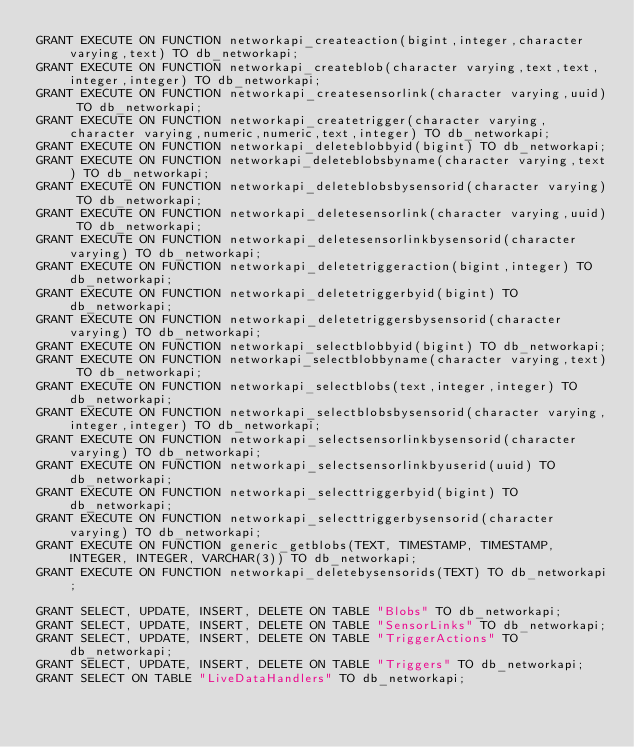<code> <loc_0><loc_0><loc_500><loc_500><_SQL_>GRANT EXECUTE ON FUNCTION networkapi_createaction(bigint,integer,character varying,text) TO db_networkapi;
GRANT EXECUTE ON FUNCTION networkapi_createblob(character varying,text,text,integer,integer) TO db_networkapi;
GRANT EXECUTE ON FUNCTION networkapi_createsensorlink(character varying,uuid) TO db_networkapi;
GRANT EXECUTE ON FUNCTION networkapi_createtrigger(character varying,character varying,numeric,numeric,text,integer) TO db_networkapi;
GRANT EXECUTE ON FUNCTION networkapi_deleteblobbyid(bigint) TO db_networkapi;
GRANT EXECUTE ON FUNCTION networkapi_deleteblobsbyname(character varying,text) TO db_networkapi;
GRANT EXECUTE ON FUNCTION networkapi_deleteblobsbysensorid(character varying) TO db_networkapi;
GRANT EXECUTE ON FUNCTION networkapi_deletesensorlink(character varying,uuid) TO db_networkapi;
GRANT EXECUTE ON FUNCTION networkapi_deletesensorlinkbysensorid(character varying) TO db_networkapi;
GRANT EXECUTE ON FUNCTION networkapi_deletetriggeraction(bigint,integer) TO db_networkapi;
GRANT EXECUTE ON FUNCTION networkapi_deletetriggerbyid(bigint) TO db_networkapi;
GRANT EXECUTE ON FUNCTION networkapi_deletetriggersbysensorid(character varying) TO db_networkapi;
GRANT EXECUTE ON FUNCTION networkapi_selectblobbyid(bigint) TO db_networkapi;
GRANT EXECUTE ON FUNCTION networkapi_selectblobbyname(character varying,text) TO db_networkapi;
GRANT EXECUTE ON FUNCTION networkapi_selectblobs(text,integer,integer) TO db_networkapi;
GRANT EXECUTE ON FUNCTION networkapi_selectblobsbysensorid(character varying,integer,integer) TO db_networkapi;
GRANT EXECUTE ON FUNCTION networkapi_selectsensorlinkbysensorid(character varying) TO db_networkapi;
GRANT EXECUTE ON FUNCTION networkapi_selectsensorlinkbyuserid(uuid) TO db_networkapi;
GRANT EXECUTE ON FUNCTION networkapi_selecttriggerbyid(bigint) TO db_networkapi;
GRANT EXECUTE ON FUNCTION networkapi_selecttriggerbysensorid(character varying) TO db_networkapi;
GRANT EXECUTE ON FUNCTION generic_getblobs(TEXT, TIMESTAMP, TIMESTAMP, INTEGER, INTEGER, VARCHAR(3)) TO db_networkapi;
GRANT EXECUTE ON FUNCTION networkapi_deletebysensorids(TEXT) TO db_networkapi;

GRANT SELECT, UPDATE, INSERT, DELETE ON TABLE "Blobs" TO db_networkapi;
GRANT SELECT, UPDATE, INSERT, DELETE ON TABLE "SensorLinks" TO db_networkapi;
GRANT SELECT, UPDATE, INSERT, DELETE ON TABLE "TriggerActions" TO db_networkapi;
GRANT SELECT, UPDATE, INSERT, DELETE ON TABLE "Triggers" TO db_networkapi;
GRANT SELECT ON TABLE "LiveDataHandlers" TO db_networkapi;
</code> 